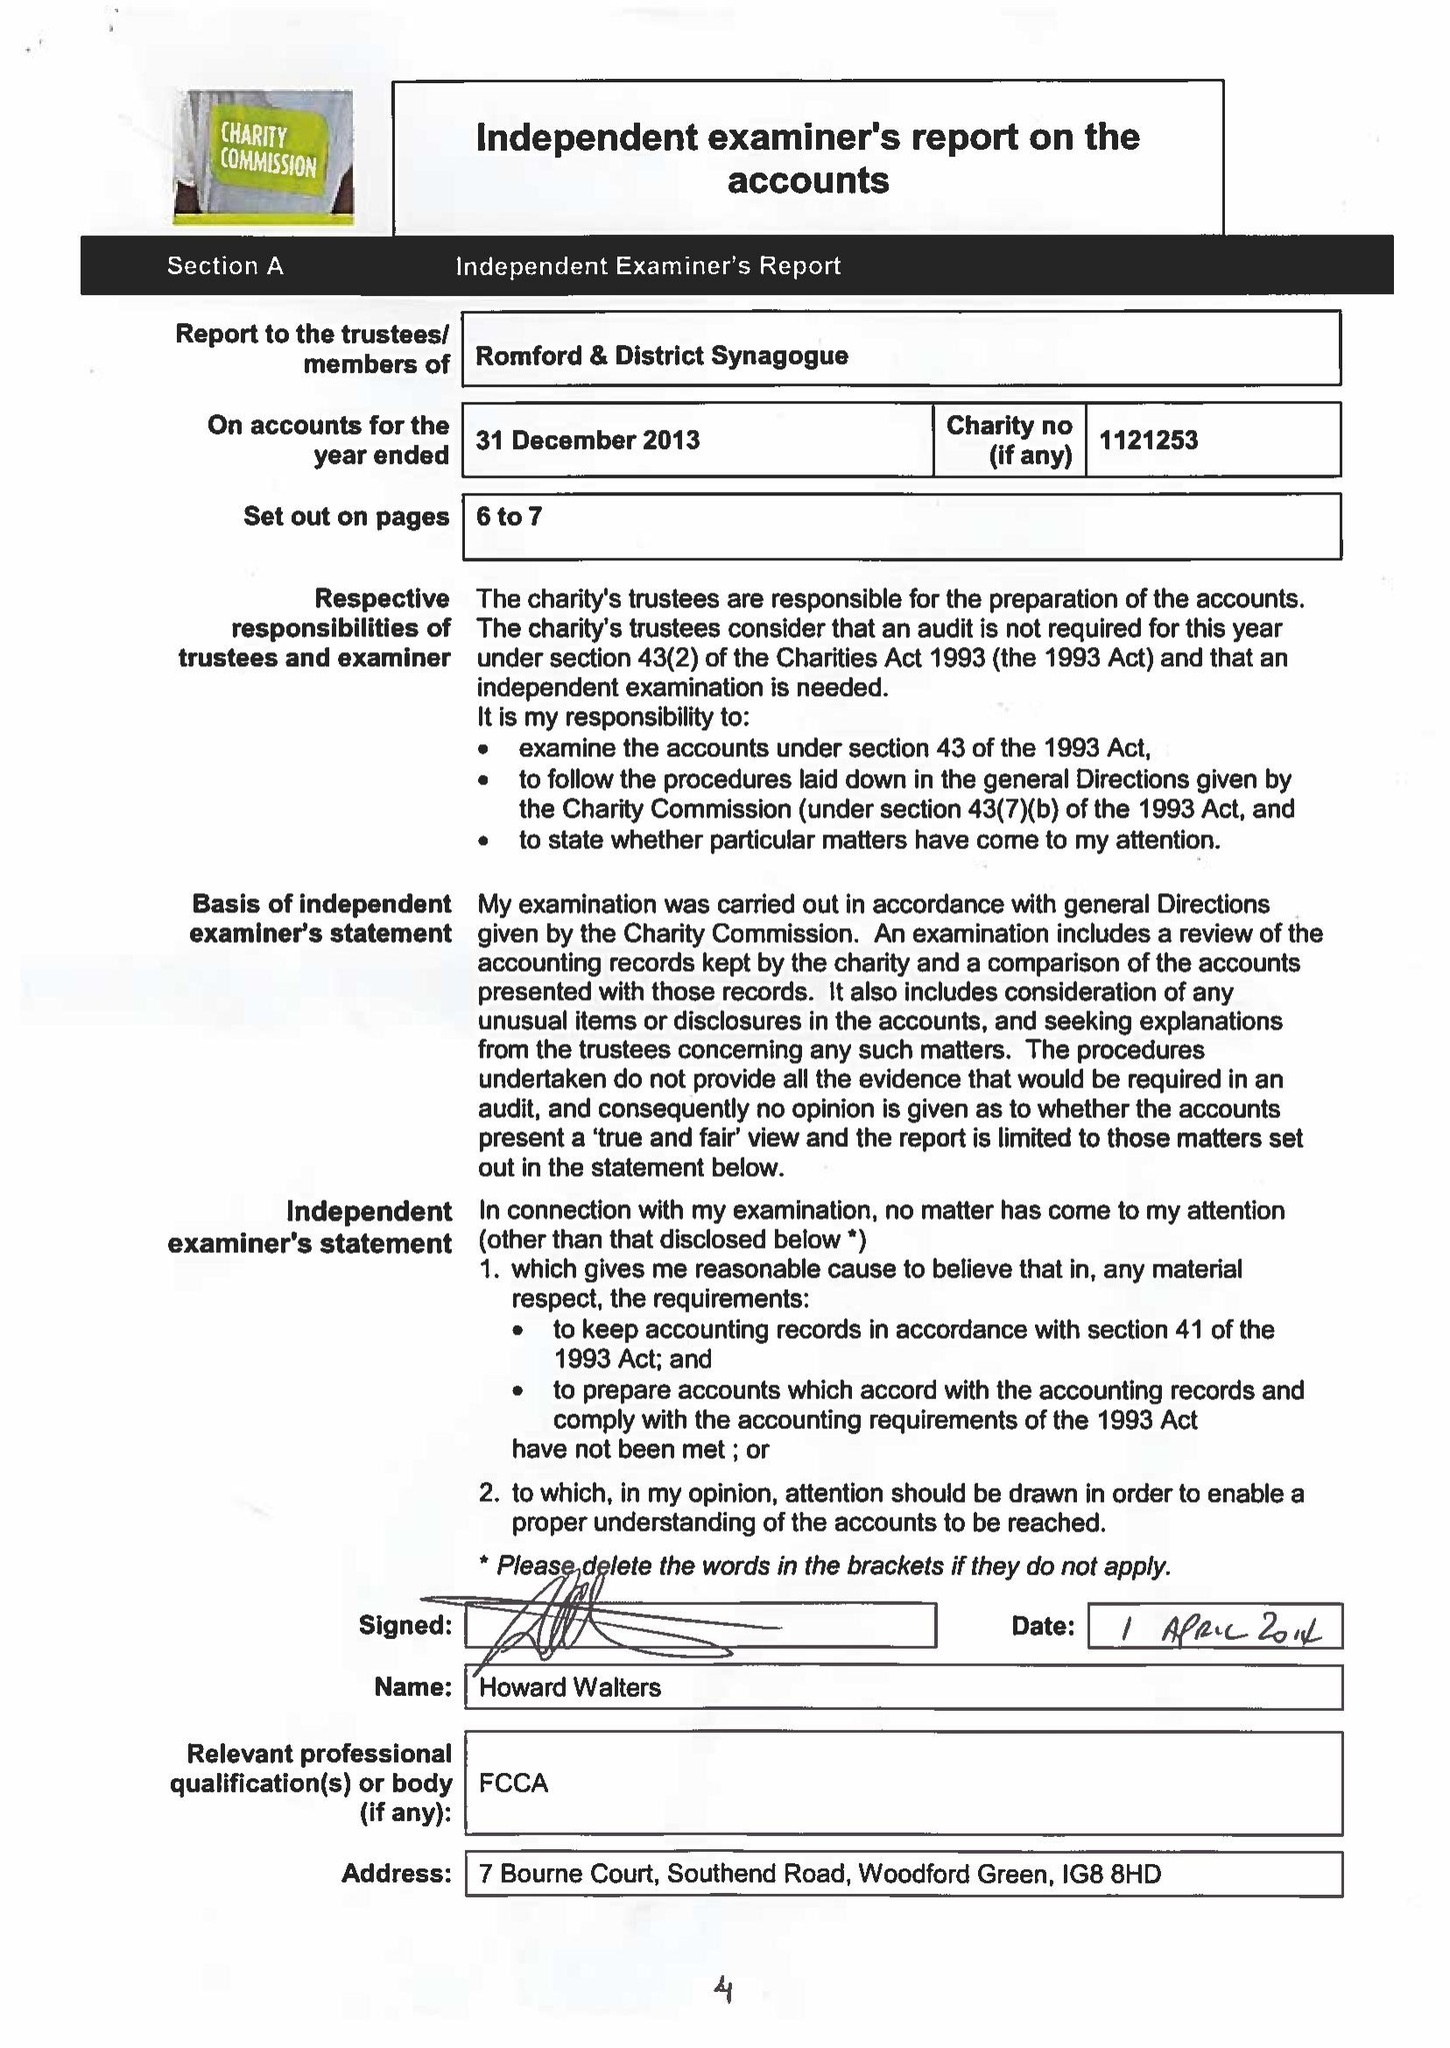What is the value for the spending_annually_in_british_pounds?
Answer the question using a single word or phrase. 62826.00 